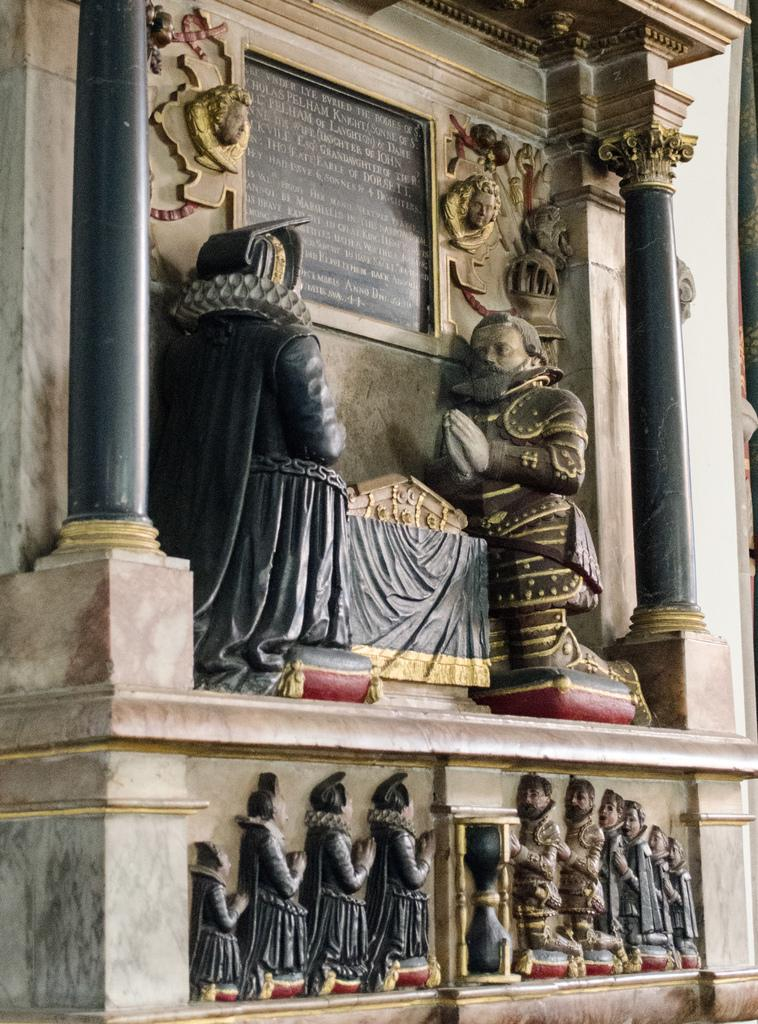What can be seen on the wall in the image? There are statues on the wall in the image. What is the material at the top of the image? There is black stone at the top of the image. What is written on the black stone? Something is written on the black stone. What color are the pillars on the sides of the image? There are green color pillars on the right and left sides of the image. What type of punishment is depicted in the image? There is no punishment depicted in the image; it features statues, black stone, and green pillars. Does the image show the existence of zinc? There is no mention or indication of zinc in the image. 